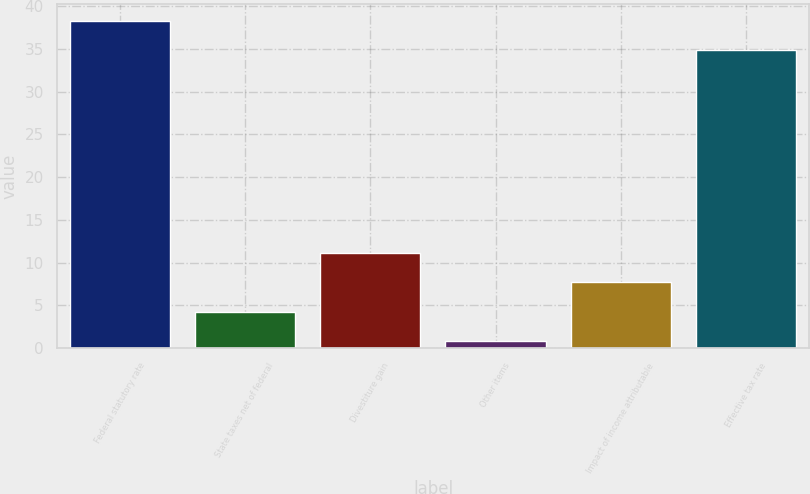<chart> <loc_0><loc_0><loc_500><loc_500><bar_chart><fcel>Federal statutory rate<fcel>State taxes net of federal<fcel>Divestiture gain<fcel>Other items<fcel>Impact of income attributable<fcel>Effective tax rate<nl><fcel>38.32<fcel>4.26<fcel>11.1<fcel>0.84<fcel>7.68<fcel>34.9<nl></chart> 